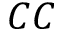Convert formula to latex. <formula><loc_0><loc_0><loc_500><loc_500>C C</formula> 